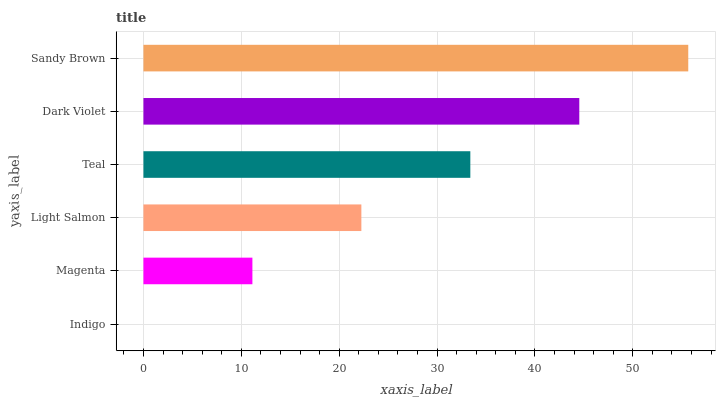Is Indigo the minimum?
Answer yes or no. Yes. Is Sandy Brown the maximum?
Answer yes or no. Yes. Is Magenta the minimum?
Answer yes or no. No. Is Magenta the maximum?
Answer yes or no. No. Is Magenta greater than Indigo?
Answer yes or no. Yes. Is Indigo less than Magenta?
Answer yes or no. Yes. Is Indigo greater than Magenta?
Answer yes or no. No. Is Magenta less than Indigo?
Answer yes or no. No. Is Teal the high median?
Answer yes or no. Yes. Is Light Salmon the low median?
Answer yes or no. Yes. Is Sandy Brown the high median?
Answer yes or no. No. Is Teal the low median?
Answer yes or no. No. 